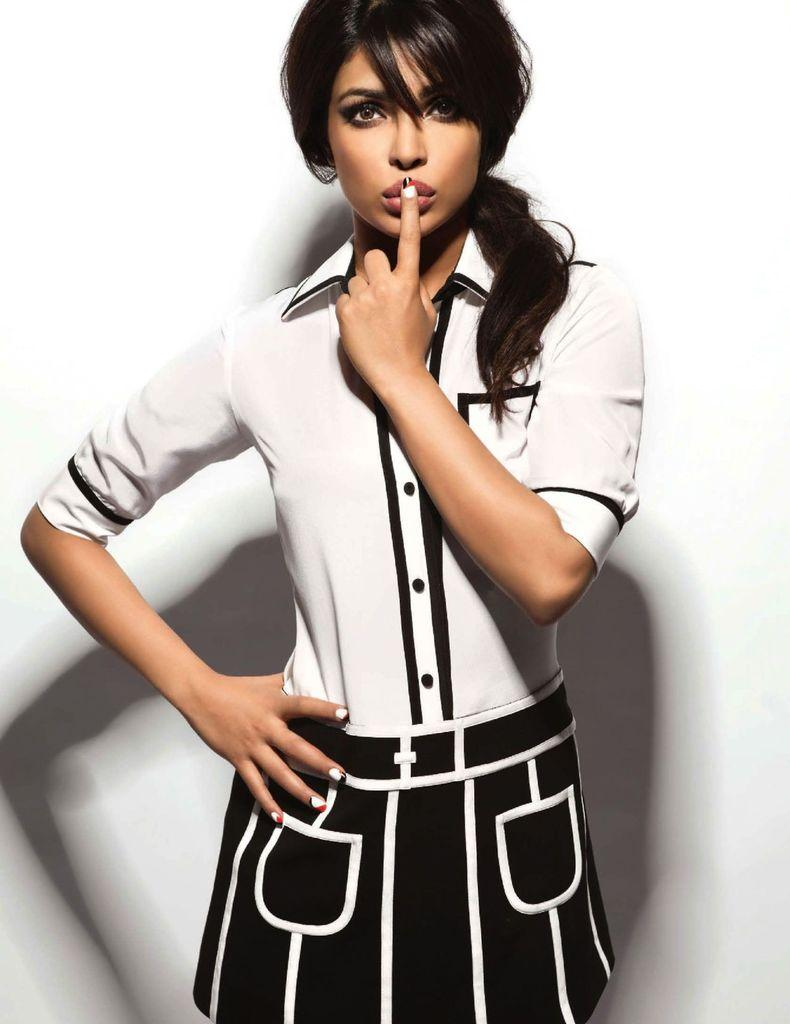Who is the main subject in the image? There is a woman in the image. What is the woman wearing on her upper body? The woman is wearing a white shirt. What is the woman wearing on her lower body? The woman is wearing a black frock. What is the background of the image? The woman is standing in front of a white wall. What type of offer is the woman making to the hen in the image? There is no hen present in the image, so it is not possible to answer that question. 